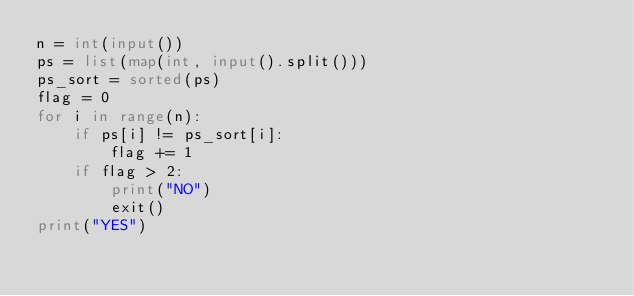Convert code to text. <code><loc_0><loc_0><loc_500><loc_500><_Python_>n = int(input())
ps = list(map(int, input().split()))
ps_sort = sorted(ps)
flag = 0
for i in range(n):
    if ps[i] != ps_sort[i]:
        flag += 1
    if flag > 2:
        print("NO")
        exit()
print("YES")</code> 